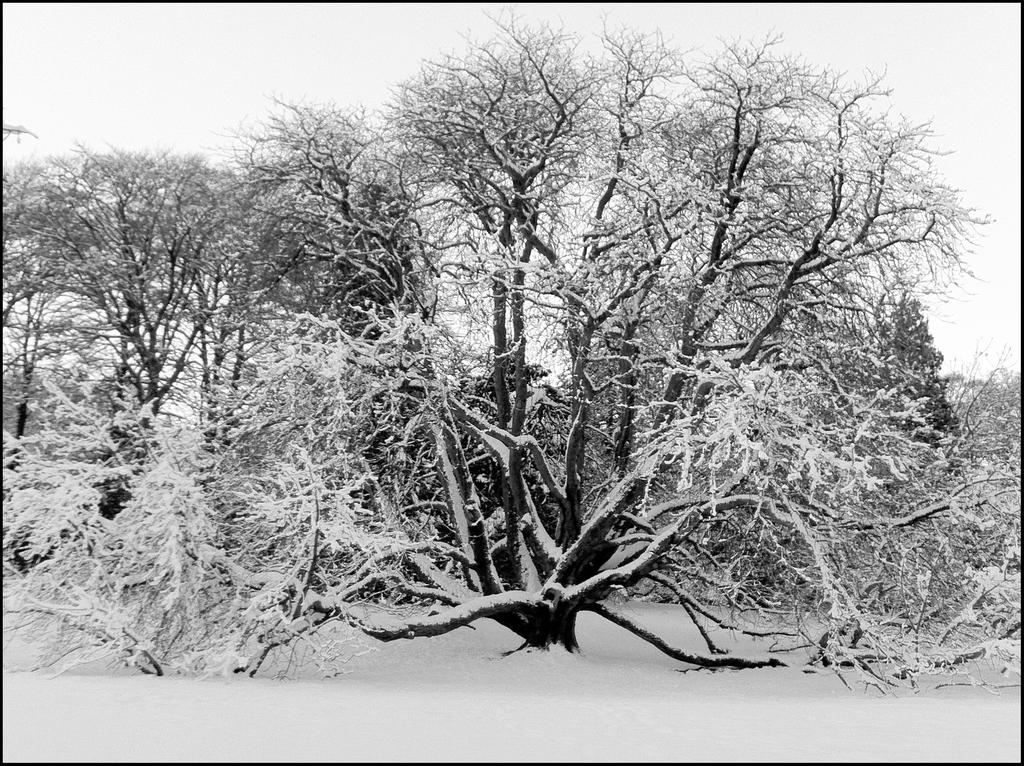What type of vegetation is present in the image? There are trees in the image. What is the condition of the trees in the image? The trees are covered with snow. What is the condition of the ground in the image? There is snow on the ground. What is the condition of the sky in the image? The sky is clear. How many icicles can be seen hanging from the trees in the image? There are no icicles visible in the image; only snow-covered trees are present. What type of bird can be seen perched on the branches of the trees in the image? There are no birds visible in the image; only trees covered with snow are present. 